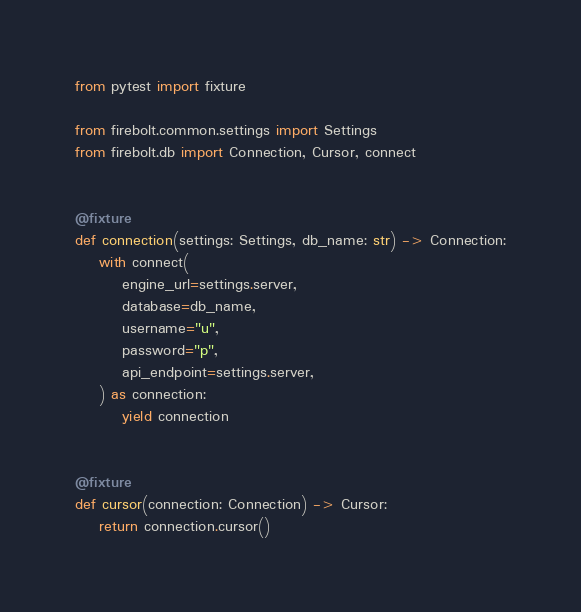Convert code to text. <code><loc_0><loc_0><loc_500><loc_500><_Python_>from pytest import fixture

from firebolt.common.settings import Settings
from firebolt.db import Connection, Cursor, connect


@fixture
def connection(settings: Settings, db_name: str) -> Connection:
    with connect(
        engine_url=settings.server,
        database=db_name,
        username="u",
        password="p",
        api_endpoint=settings.server,
    ) as connection:
        yield connection


@fixture
def cursor(connection: Connection) -> Cursor:
    return connection.cursor()
</code> 